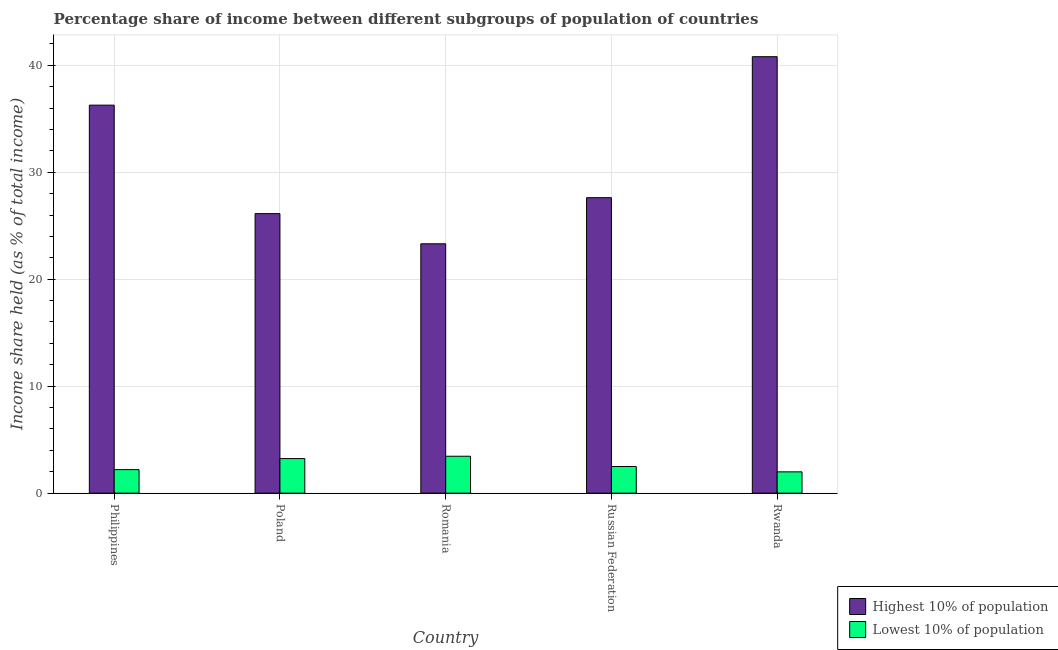How many different coloured bars are there?
Provide a short and direct response. 2. How many groups of bars are there?
Offer a very short reply. 5. Are the number of bars per tick equal to the number of legend labels?
Give a very brief answer. Yes. Are the number of bars on each tick of the X-axis equal?
Ensure brevity in your answer.  Yes. How many bars are there on the 1st tick from the left?
Offer a very short reply. 2. What is the label of the 3rd group of bars from the left?
Your answer should be compact. Romania. In how many cases, is the number of bars for a given country not equal to the number of legend labels?
Provide a short and direct response. 0. What is the income share held by highest 10% of the population in Poland?
Give a very brief answer. 26.13. Across all countries, what is the maximum income share held by lowest 10% of the population?
Keep it short and to the point. 3.45. Across all countries, what is the minimum income share held by lowest 10% of the population?
Offer a terse response. 1.99. In which country was the income share held by highest 10% of the population maximum?
Your response must be concise. Rwanda. In which country was the income share held by lowest 10% of the population minimum?
Provide a short and direct response. Rwanda. What is the total income share held by lowest 10% of the population in the graph?
Your answer should be compact. 13.36. What is the difference between the income share held by lowest 10% of the population in Philippines and that in Poland?
Make the answer very short. -1.03. What is the difference between the income share held by highest 10% of the population in Poland and the income share held by lowest 10% of the population in Rwanda?
Keep it short and to the point. 24.14. What is the average income share held by highest 10% of the population per country?
Ensure brevity in your answer.  30.83. What is the difference between the income share held by lowest 10% of the population and income share held by highest 10% of the population in Romania?
Your response must be concise. -19.86. In how many countries, is the income share held by highest 10% of the population greater than 38 %?
Ensure brevity in your answer.  1. What is the ratio of the income share held by highest 10% of the population in Philippines to that in Russian Federation?
Your response must be concise. 1.31. Is the difference between the income share held by lowest 10% of the population in Philippines and Rwanda greater than the difference between the income share held by highest 10% of the population in Philippines and Rwanda?
Your answer should be compact. Yes. What is the difference between the highest and the second highest income share held by lowest 10% of the population?
Ensure brevity in your answer.  0.22. What is the difference between the highest and the lowest income share held by highest 10% of the population?
Give a very brief answer. 17.49. What does the 2nd bar from the left in Romania represents?
Provide a succinct answer. Lowest 10% of population. What does the 1st bar from the right in Romania represents?
Your answer should be very brief. Lowest 10% of population. How many bars are there?
Make the answer very short. 10. Are all the bars in the graph horizontal?
Your response must be concise. No. How many countries are there in the graph?
Your response must be concise. 5. Are the values on the major ticks of Y-axis written in scientific E-notation?
Give a very brief answer. No. Does the graph contain any zero values?
Offer a very short reply. No. Where does the legend appear in the graph?
Keep it short and to the point. Bottom right. How many legend labels are there?
Your answer should be very brief. 2. What is the title of the graph?
Make the answer very short. Percentage share of income between different subgroups of population of countries. Does "Net National savings" appear as one of the legend labels in the graph?
Your answer should be very brief. No. What is the label or title of the X-axis?
Make the answer very short. Country. What is the label or title of the Y-axis?
Keep it short and to the point. Income share held (as % of total income). What is the Income share held (as % of total income) in Highest 10% of population in Philippines?
Your response must be concise. 36.27. What is the Income share held (as % of total income) of Highest 10% of population in Poland?
Make the answer very short. 26.13. What is the Income share held (as % of total income) in Lowest 10% of population in Poland?
Provide a short and direct response. 3.23. What is the Income share held (as % of total income) of Highest 10% of population in Romania?
Offer a terse response. 23.31. What is the Income share held (as % of total income) of Lowest 10% of population in Romania?
Your answer should be compact. 3.45. What is the Income share held (as % of total income) of Highest 10% of population in Russian Federation?
Offer a very short reply. 27.62. What is the Income share held (as % of total income) in Lowest 10% of population in Russian Federation?
Your answer should be compact. 2.49. What is the Income share held (as % of total income) of Highest 10% of population in Rwanda?
Make the answer very short. 40.8. What is the Income share held (as % of total income) in Lowest 10% of population in Rwanda?
Offer a terse response. 1.99. Across all countries, what is the maximum Income share held (as % of total income) in Highest 10% of population?
Keep it short and to the point. 40.8. Across all countries, what is the maximum Income share held (as % of total income) of Lowest 10% of population?
Provide a short and direct response. 3.45. Across all countries, what is the minimum Income share held (as % of total income) of Highest 10% of population?
Offer a terse response. 23.31. Across all countries, what is the minimum Income share held (as % of total income) of Lowest 10% of population?
Keep it short and to the point. 1.99. What is the total Income share held (as % of total income) in Highest 10% of population in the graph?
Ensure brevity in your answer.  154.13. What is the total Income share held (as % of total income) of Lowest 10% of population in the graph?
Your answer should be very brief. 13.36. What is the difference between the Income share held (as % of total income) of Highest 10% of population in Philippines and that in Poland?
Make the answer very short. 10.14. What is the difference between the Income share held (as % of total income) in Lowest 10% of population in Philippines and that in Poland?
Provide a succinct answer. -1.03. What is the difference between the Income share held (as % of total income) of Highest 10% of population in Philippines and that in Romania?
Offer a very short reply. 12.96. What is the difference between the Income share held (as % of total income) in Lowest 10% of population in Philippines and that in Romania?
Make the answer very short. -1.25. What is the difference between the Income share held (as % of total income) in Highest 10% of population in Philippines and that in Russian Federation?
Your response must be concise. 8.65. What is the difference between the Income share held (as % of total income) of Lowest 10% of population in Philippines and that in Russian Federation?
Your answer should be compact. -0.29. What is the difference between the Income share held (as % of total income) of Highest 10% of population in Philippines and that in Rwanda?
Keep it short and to the point. -4.53. What is the difference between the Income share held (as % of total income) of Lowest 10% of population in Philippines and that in Rwanda?
Provide a succinct answer. 0.21. What is the difference between the Income share held (as % of total income) in Highest 10% of population in Poland and that in Romania?
Give a very brief answer. 2.82. What is the difference between the Income share held (as % of total income) of Lowest 10% of population in Poland and that in Romania?
Provide a short and direct response. -0.22. What is the difference between the Income share held (as % of total income) in Highest 10% of population in Poland and that in Russian Federation?
Offer a very short reply. -1.49. What is the difference between the Income share held (as % of total income) of Lowest 10% of population in Poland and that in Russian Federation?
Provide a succinct answer. 0.74. What is the difference between the Income share held (as % of total income) of Highest 10% of population in Poland and that in Rwanda?
Give a very brief answer. -14.67. What is the difference between the Income share held (as % of total income) of Lowest 10% of population in Poland and that in Rwanda?
Keep it short and to the point. 1.24. What is the difference between the Income share held (as % of total income) of Highest 10% of population in Romania and that in Russian Federation?
Provide a succinct answer. -4.31. What is the difference between the Income share held (as % of total income) in Lowest 10% of population in Romania and that in Russian Federation?
Provide a succinct answer. 0.96. What is the difference between the Income share held (as % of total income) in Highest 10% of population in Romania and that in Rwanda?
Give a very brief answer. -17.49. What is the difference between the Income share held (as % of total income) of Lowest 10% of population in Romania and that in Rwanda?
Offer a very short reply. 1.46. What is the difference between the Income share held (as % of total income) of Highest 10% of population in Russian Federation and that in Rwanda?
Your answer should be very brief. -13.18. What is the difference between the Income share held (as % of total income) in Highest 10% of population in Philippines and the Income share held (as % of total income) in Lowest 10% of population in Poland?
Make the answer very short. 33.04. What is the difference between the Income share held (as % of total income) of Highest 10% of population in Philippines and the Income share held (as % of total income) of Lowest 10% of population in Romania?
Give a very brief answer. 32.82. What is the difference between the Income share held (as % of total income) of Highest 10% of population in Philippines and the Income share held (as % of total income) of Lowest 10% of population in Russian Federation?
Make the answer very short. 33.78. What is the difference between the Income share held (as % of total income) of Highest 10% of population in Philippines and the Income share held (as % of total income) of Lowest 10% of population in Rwanda?
Offer a very short reply. 34.28. What is the difference between the Income share held (as % of total income) of Highest 10% of population in Poland and the Income share held (as % of total income) of Lowest 10% of population in Romania?
Ensure brevity in your answer.  22.68. What is the difference between the Income share held (as % of total income) of Highest 10% of population in Poland and the Income share held (as % of total income) of Lowest 10% of population in Russian Federation?
Provide a succinct answer. 23.64. What is the difference between the Income share held (as % of total income) in Highest 10% of population in Poland and the Income share held (as % of total income) in Lowest 10% of population in Rwanda?
Offer a very short reply. 24.14. What is the difference between the Income share held (as % of total income) of Highest 10% of population in Romania and the Income share held (as % of total income) of Lowest 10% of population in Russian Federation?
Keep it short and to the point. 20.82. What is the difference between the Income share held (as % of total income) in Highest 10% of population in Romania and the Income share held (as % of total income) in Lowest 10% of population in Rwanda?
Ensure brevity in your answer.  21.32. What is the difference between the Income share held (as % of total income) in Highest 10% of population in Russian Federation and the Income share held (as % of total income) in Lowest 10% of population in Rwanda?
Ensure brevity in your answer.  25.63. What is the average Income share held (as % of total income) of Highest 10% of population per country?
Your answer should be very brief. 30.83. What is the average Income share held (as % of total income) of Lowest 10% of population per country?
Provide a short and direct response. 2.67. What is the difference between the Income share held (as % of total income) in Highest 10% of population and Income share held (as % of total income) in Lowest 10% of population in Philippines?
Give a very brief answer. 34.07. What is the difference between the Income share held (as % of total income) in Highest 10% of population and Income share held (as % of total income) in Lowest 10% of population in Poland?
Provide a short and direct response. 22.9. What is the difference between the Income share held (as % of total income) in Highest 10% of population and Income share held (as % of total income) in Lowest 10% of population in Romania?
Your answer should be very brief. 19.86. What is the difference between the Income share held (as % of total income) of Highest 10% of population and Income share held (as % of total income) of Lowest 10% of population in Russian Federation?
Make the answer very short. 25.13. What is the difference between the Income share held (as % of total income) in Highest 10% of population and Income share held (as % of total income) in Lowest 10% of population in Rwanda?
Ensure brevity in your answer.  38.81. What is the ratio of the Income share held (as % of total income) of Highest 10% of population in Philippines to that in Poland?
Provide a succinct answer. 1.39. What is the ratio of the Income share held (as % of total income) of Lowest 10% of population in Philippines to that in Poland?
Give a very brief answer. 0.68. What is the ratio of the Income share held (as % of total income) in Highest 10% of population in Philippines to that in Romania?
Your answer should be compact. 1.56. What is the ratio of the Income share held (as % of total income) in Lowest 10% of population in Philippines to that in Romania?
Your answer should be compact. 0.64. What is the ratio of the Income share held (as % of total income) of Highest 10% of population in Philippines to that in Russian Federation?
Offer a very short reply. 1.31. What is the ratio of the Income share held (as % of total income) in Lowest 10% of population in Philippines to that in Russian Federation?
Keep it short and to the point. 0.88. What is the ratio of the Income share held (as % of total income) in Highest 10% of population in Philippines to that in Rwanda?
Keep it short and to the point. 0.89. What is the ratio of the Income share held (as % of total income) in Lowest 10% of population in Philippines to that in Rwanda?
Your response must be concise. 1.11. What is the ratio of the Income share held (as % of total income) of Highest 10% of population in Poland to that in Romania?
Make the answer very short. 1.12. What is the ratio of the Income share held (as % of total income) of Lowest 10% of population in Poland to that in Romania?
Keep it short and to the point. 0.94. What is the ratio of the Income share held (as % of total income) of Highest 10% of population in Poland to that in Russian Federation?
Provide a short and direct response. 0.95. What is the ratio of the Income share held (as % of total income) in Lowest 10% of population in Poland to that in Russian Federation?
Your answer should be compact. 1.3. What is the ratio of the Income share held (as % of total income) in Highest 10% of population in Poland to that in Rwanda?
Keep it short and to the point. 0.64. What is the ratio of the Income share held (as % of total income) of Lowest 10% of population in Poland to that in Rwanda?
Ensure brevity in your answer.  1.62. What is the ratio of the Income share held (as % of total income) in Highest 10% of population in Romania to that in Russian Federation?
Your answer should be compact. 0.84. What is the ratio of the Income share held (as % of total income) of Lowest 10% of population in Romania to that in Russian Federation?
Ensure brevity in your answer.  1.39. What is the ratio of the Income share held (as % of total income) in Highest 10% of population in Romania to that in Rwanda?
Ensure brevity in your answer.  0.57. What is the ratio of the Income share held (as % of total income) of Lowest 10% of population in Romania to that in Rwanda?
Offer a terse response. 1.73. What is the ratio of the Income share held (as % of total income) in Highest 10% of population in Russian Federation to that in Rwanda?
Offer a very short reply. 0.68. What is the ratio of the Income share held (as % of total income) of Lowest 10% of population in Russian Federation to that in Rwanda?
Offer a terse response. 1.25. What is the difference between the highest and the second highest Income share held (as % of total income) of Highest 10% of population?
Make the answer very short. 4.53. What is the difference between the highest and the second highest Income share held (as % of total income) in Lowest 10% of population?
Ensure brevity in your answer.  0.22. What is the difference between the highest and the lowest Income share held (as % of total income) of Highest 10% of population?
Keep it short and to the point. 17.49. What is the difference between the highest and the lowest Income share held (as % of total income) of Lowest 10% of population?
Ensure brevity in your answer.  1.46. 